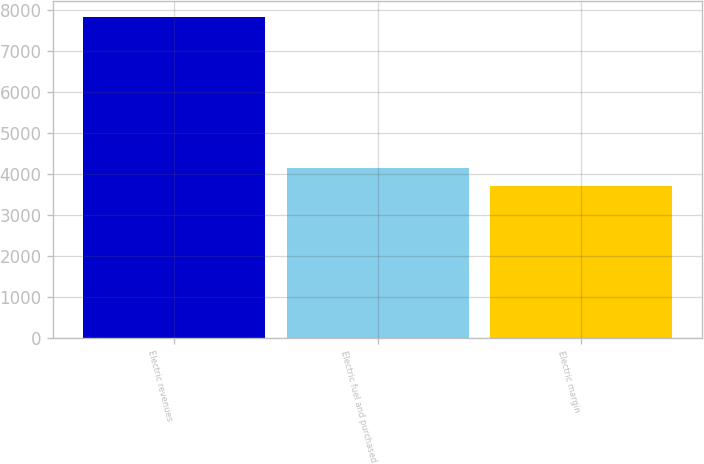Convert chart to OTSL. <chart><loc_0><loc_0><loc_500><loc_500><bar_chart><fcel>Electric revenues<fcel>Electric fuel and purchased<fcel>Electric margin<nl><fcel>7848<fcel>4137<fcel>3711<nl></chart> 